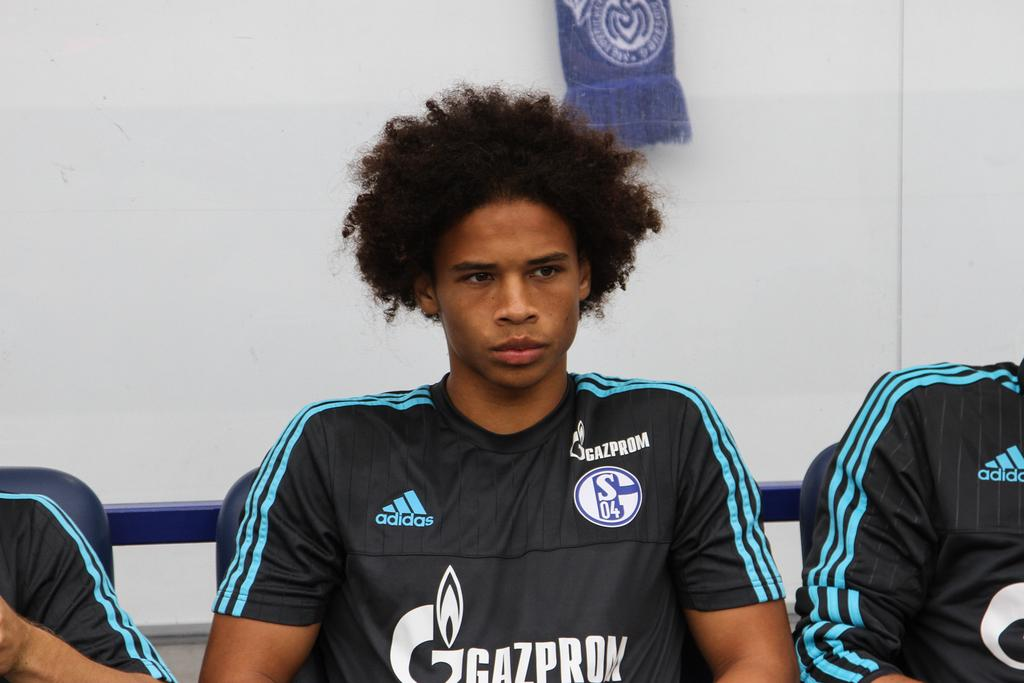<image>
Offer a succinct explanation of the picture presented. Athlete wearing a jersey that says Adidas on it. 